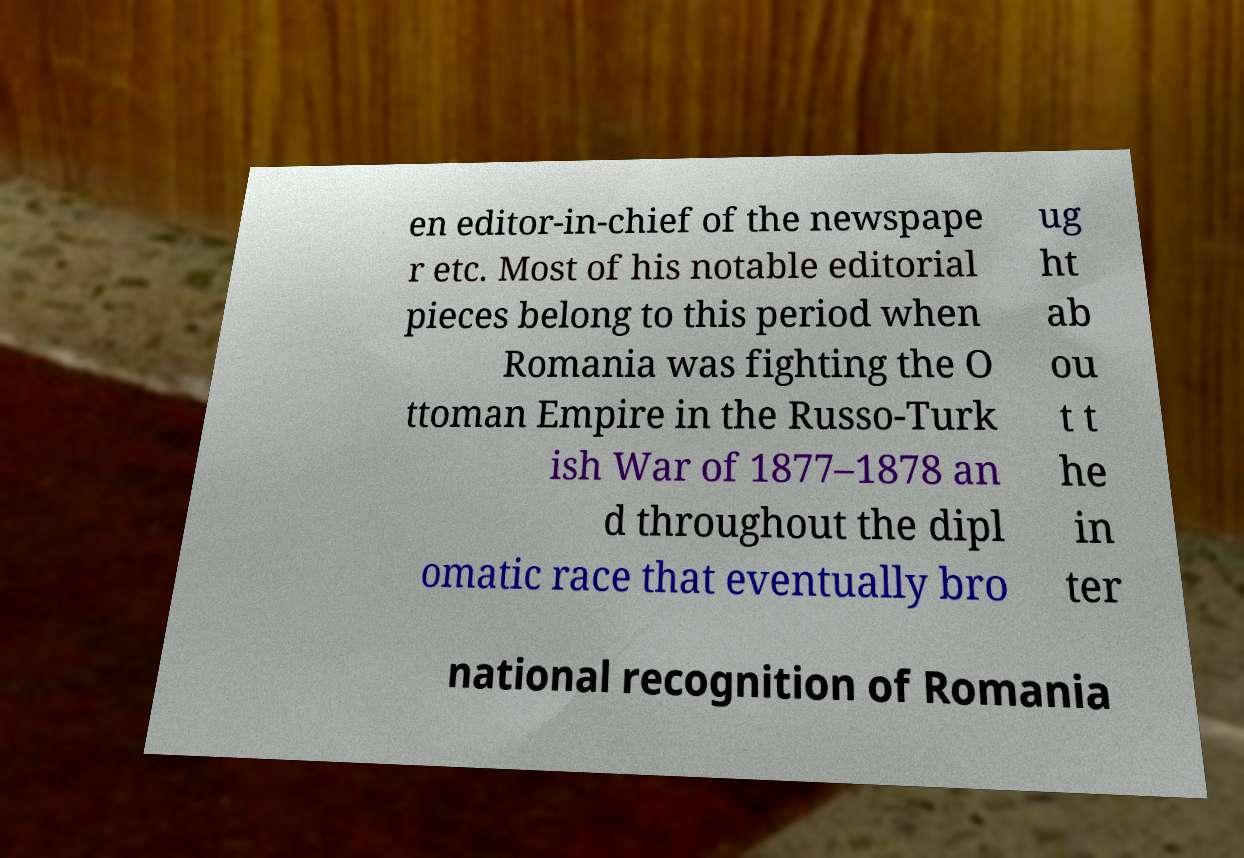Could you extract and type out the text from this image? en editor-in-chief of the newspape r etc. Most of his notable editorial pieces belong to this period when Romania was fighting the O ttoman Empire in the Russo-Turk ish War of 1877–1878 an d throughout the dipl omatic race that eventually bro ug ht ab ou t t he in ter national recognition of Romania 